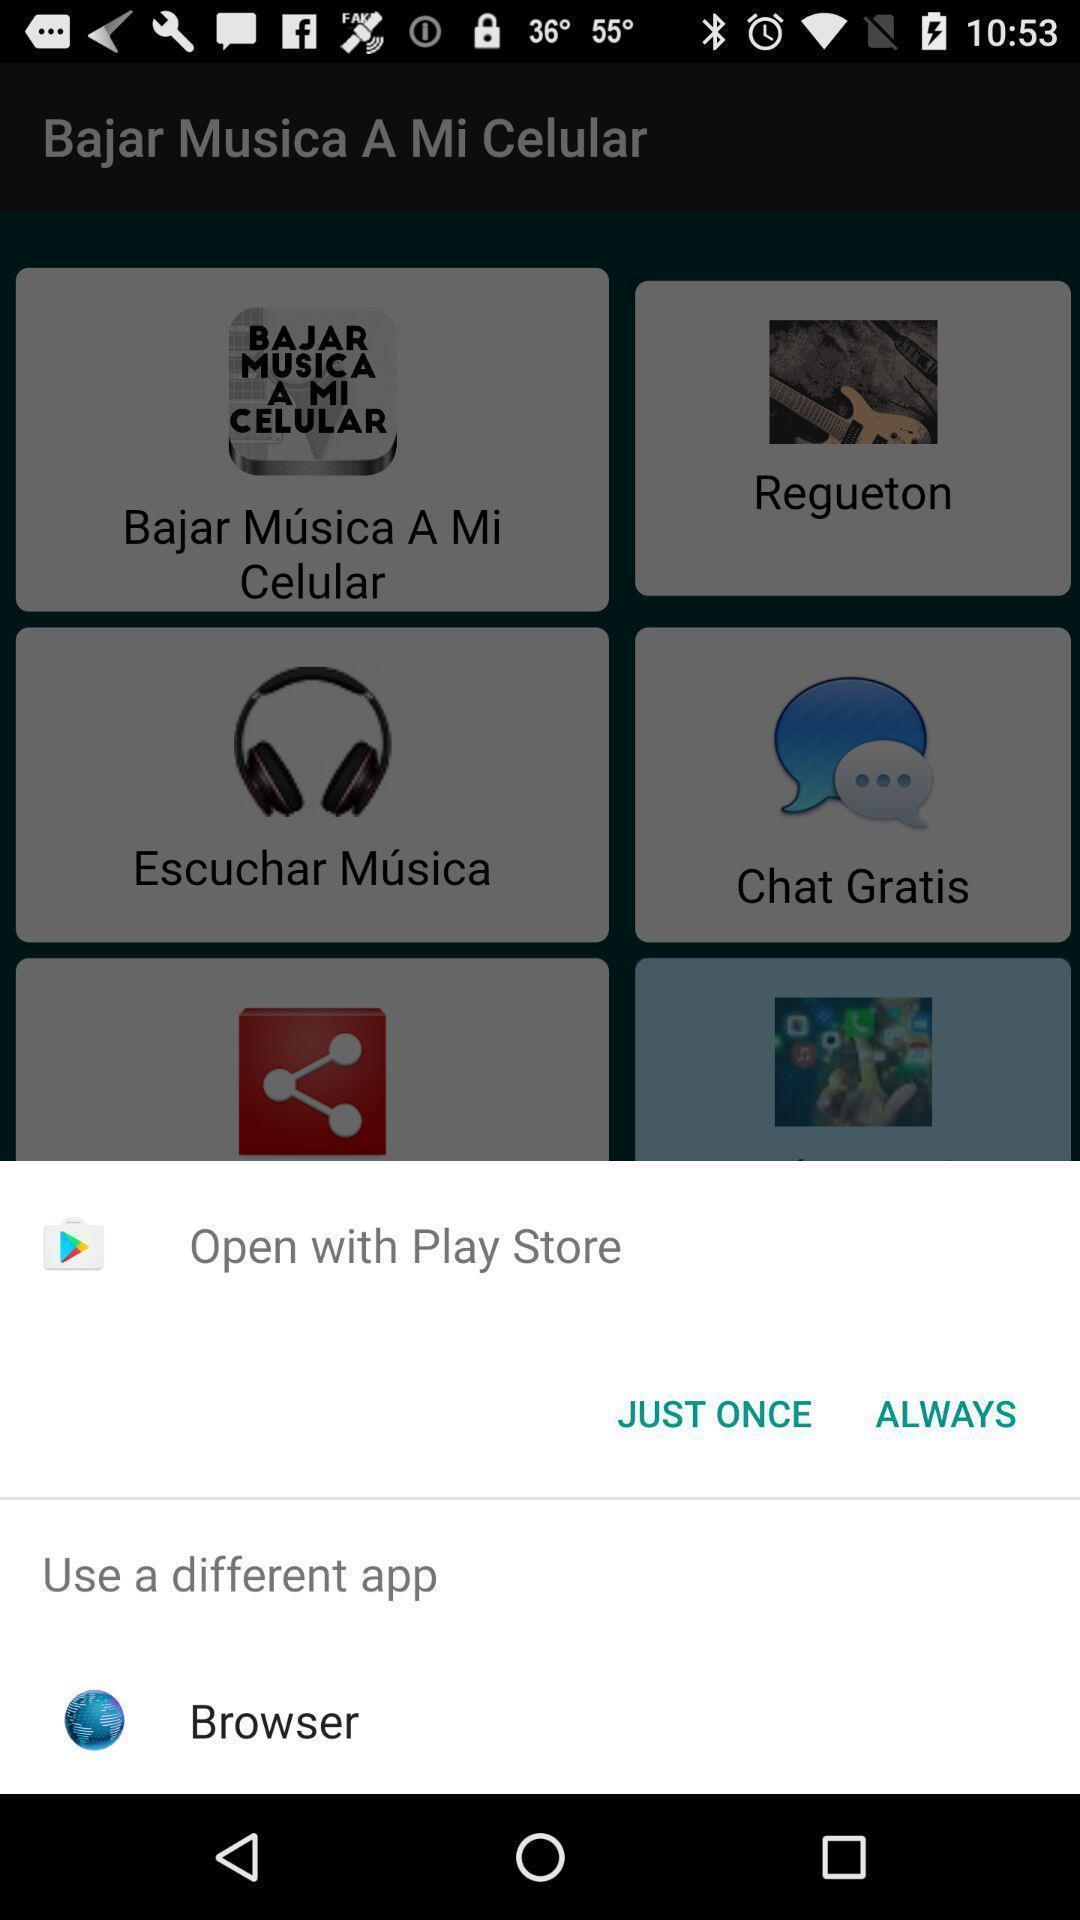Explain the elements present in this screenshot. Widget is displaying browsing options. 